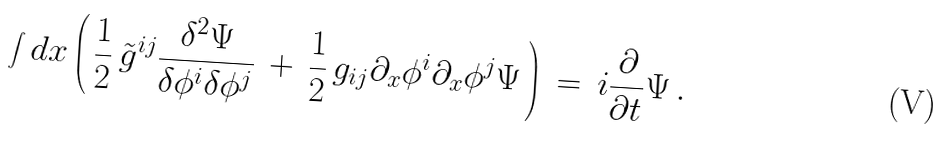Convert formula to latex. <formula><loc_0><loc_0><loc_500><loc_500>\int d x \left ( \, { \frac { 1 } { 2 } } \, \tilde { g } ^ { i j } { \frac { \delta ^ { 2 } \Psi } { \delta \phi ^ { i } \delta \phi ^ { j } } } \, + \, { \frac { 1 } { 2 } } \, g _ { i j } \partial _ { x } \phi ^ { i } \partial _ { x } \phi ^ { j } \Psi \, \right ) \, = \, i { \frac { \partial } { \partial t } } \Psi \, .</formula> 